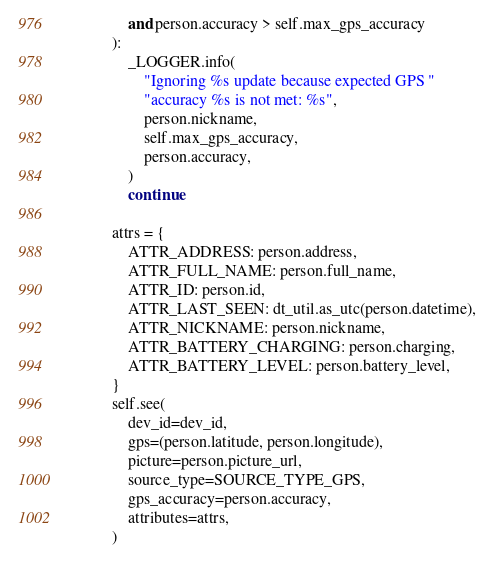Convert code to text. <code><loc_0><loc_0><loc_500><loc_500><_Python_>                and person.accuracy > self.max_gps_accuracy
            ):
                _LOGGER.info(
                    "Ignoring %s update because expected GPS "
                    "accuracy %s is not met: %s",
                    person.nickname,
                    self.max_gps_accuracy,
                    person.accuracy,
                )
                continue

            attrs = {
                ATTR_ADDRESS: person.address,
                ATTR_FULL_NAME: person.full_name,
                ATTR_ID: person.id,
                ATTR_LAST_SEEN: dt_util.as_utc(person.datetime),
                ATTR_NICKNAME: person.nickname,
                ATTR_BATTERY_CHARGING: person.charging,
                ATTR_BATTERY_LEVEL: person.battery_level,
            }
            self.see(
                dev_id=dev_id,
                gps=(person.latitude, person.longitude),
                picture=person.picture_url,
                source_type=SOURCE_TYPE_GPS,
                gps_accuracy=person.accuracy,
                attributes=attrs,
            )
</code> 